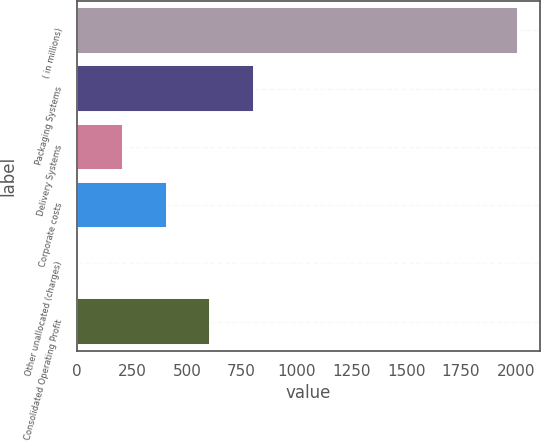<chart> <loc_0><loc_0><loc_500><loc_500><bar_chart><fcel>( in millions)<fcel>Packaging Systems<fcel>Delivery Systems<fcel>Corporate costs<fcel>Other unallocated (charges)<fcel>Consolidated Operating Profit<nl><fcel>2009<fcel>808.1<fcel>207.65<fcel>407.8<fcel>7.5<fcel>607.95<nl></chart> 